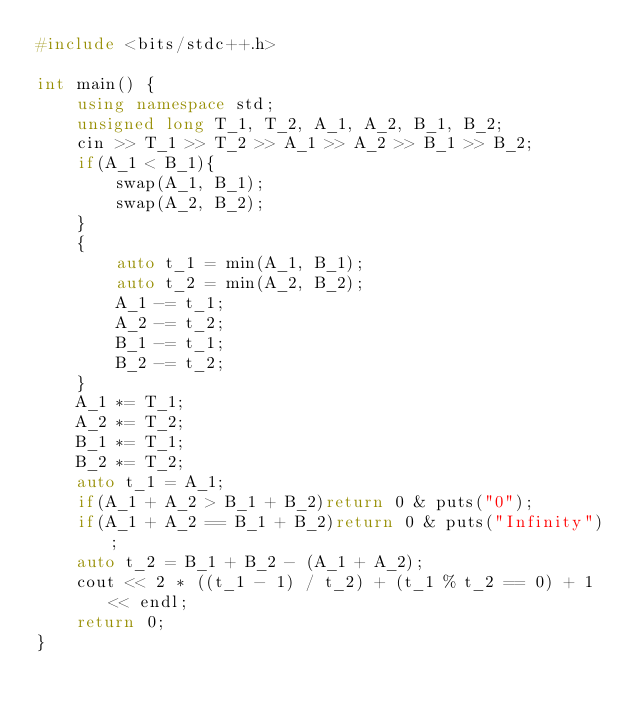<code> <loc_0><loc_0><loc_500><loc_500><_C++_>#include <bits/stdc++.h>

int main() {
    using namespace std;
    unsigned long T_1, T_2, A_1, A_2, B_1, B_2;
    cin >> T_1 >> T_2 >> A_1 >> A_2 >> B_1 >> B_2;
    if(A_1 < B_1){
        swap(A_1, B_1);
        swap(A_2, B_2);
    }
    {
        auto t_1 = min(A_1, B_1);
        auto t_2 = min(A_2, B_2);
        A_1 -= t_1;
        A_2 -= t_2;
        B_1 -= t_1;
        B_2 -= t_2;
    }
    A_1 *= T_1;
    A_2 *= T_2;
    B_1 *= T_1;
    B_2 *= T_2;
    auto t_1 = A_1;
    if(A_1 + A_2 > B_1 + B_2)return 0 & puts("0");
    if(A_1 + A_2 == B_1 + B_2)return 0 & puts("Infinity");
    auto t_2 = B_1 + B_2 - (A_1 + A_2);
    cout << 2 * ((t_1 - 1) / t_2) + (t_1 % t_2 == 0) + 1 << endl;
    return 0;
}</code> 